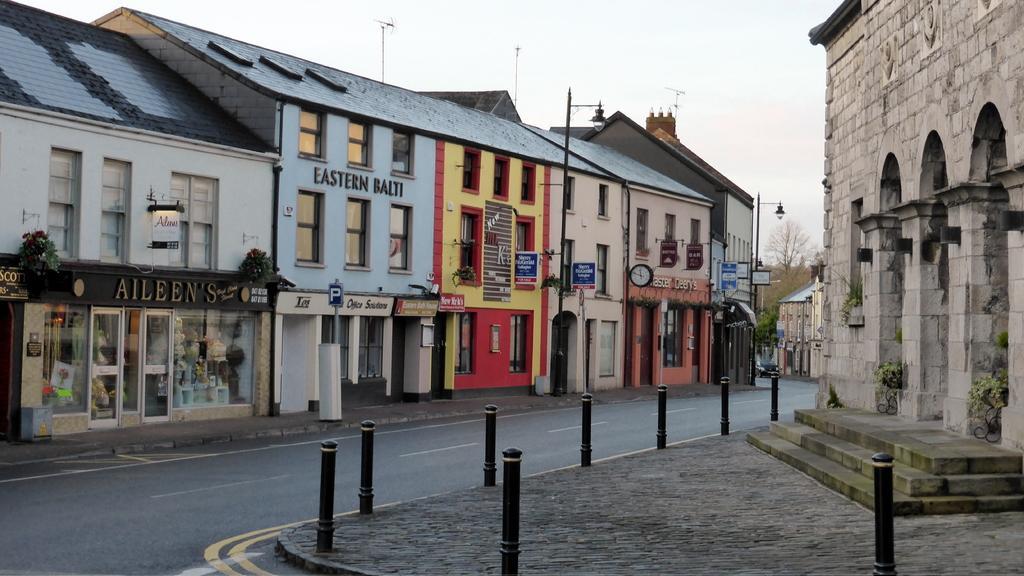Describe this image in one or two sentences. In the picture we can see a few houses adjacent to each other and we can see a shop with glasses and glass doors and name of the shop is ALEENE'S and near to it, we can see the road and opposite side, we can see a path to a part of the building and in the background we can see some tree and a pole with lamp and in the background we can see the sky. 